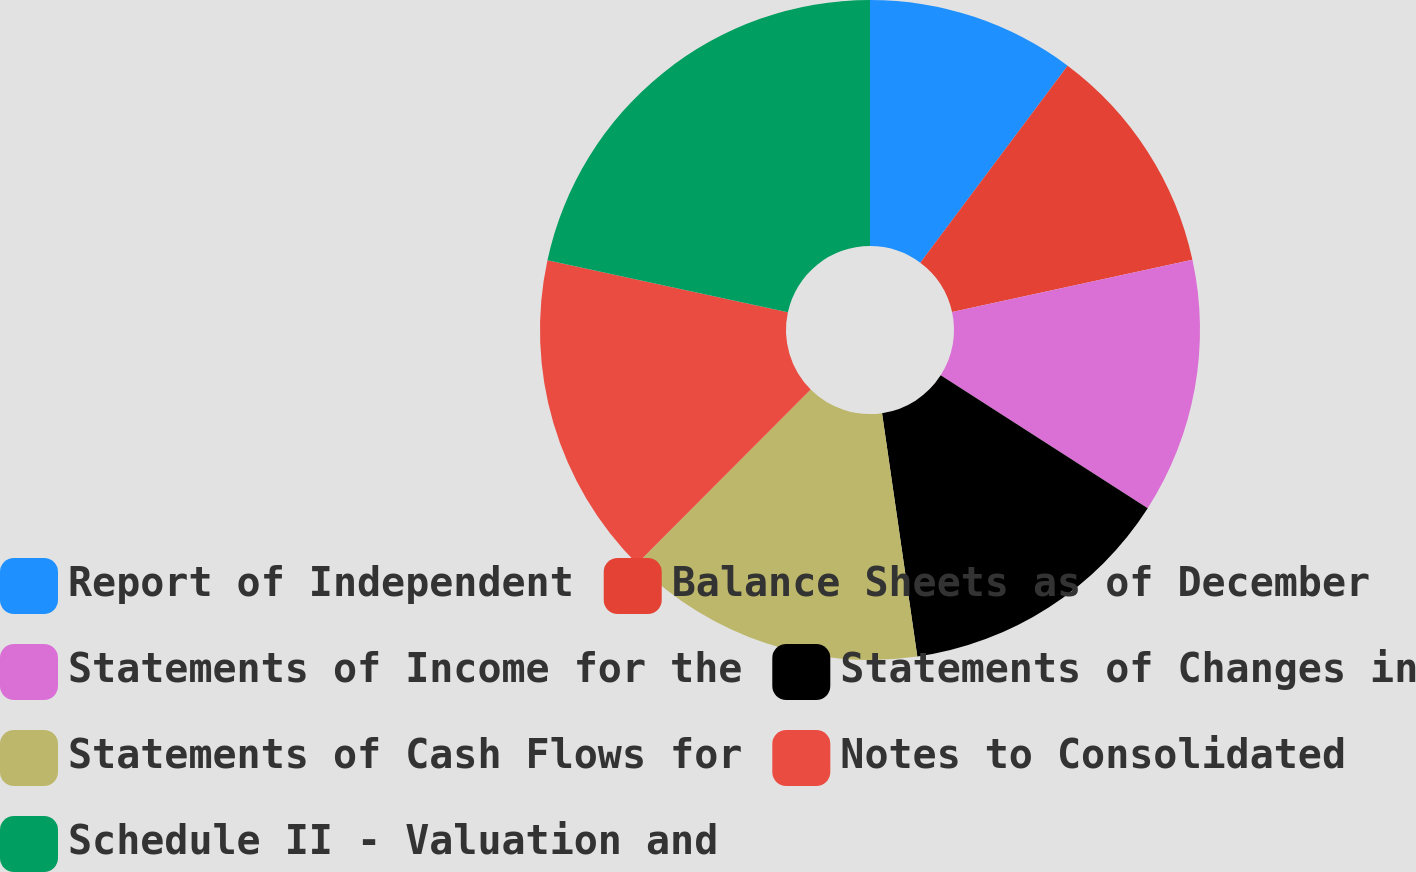Convert chart to OTSL. <chart><loc_0><loc_0><loc_500><loc_500><pie_chart><fcel>Report of Independent<fcel>Balance Sheets as of December<fcel>Statements of Income for the<fcel>Statements of Changes in<fcel>Statements of Cash Flows for<fcel>Notes to Consolidated<fcel>Schedule II - Valuation and<nl><fcel>10.22%<fcel>11.36%<fcel>12.5%<fcel>13.63%<fcel>14.77%<fcel>15.91%<fcel>21.61%<nl></chart> 